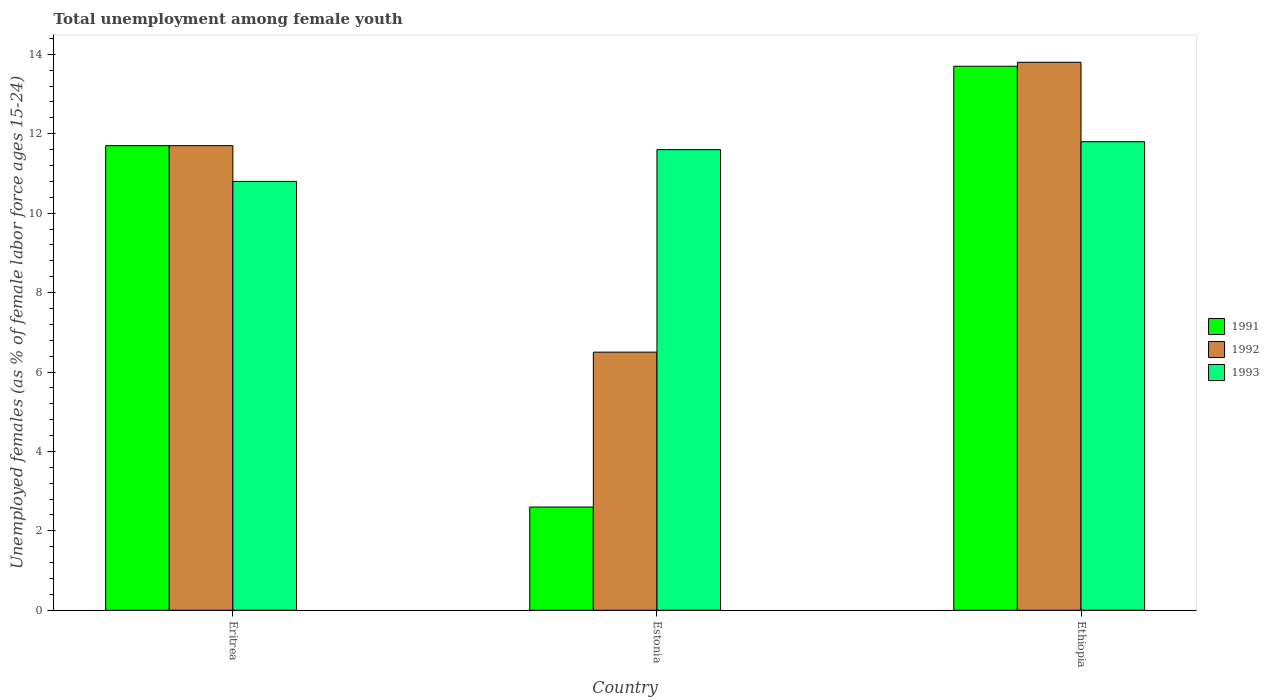Are the number of bars per tick equal to the number of legend labels?
Your response must be concise. Yes. How many bars are there on the 3rd tick from the left?
Keep it short and to the point. 3. What is the label of the 1st group of bars from the left?
Your answer should be very brief. Eritrea. What is the percentage of unemployed females in in 1993 in Ethiopia?
Offer a terse response. 11.8. Across all countries, what is the maximum percentage of unemployed females in in 1991?
Your answer should be very brief. 13.7. In which country was the percentage of unemployed females in in 1991 maximum?
Provide a succinct answer. Ethiopia. In which country was the percentage of unemployed females in in 1993 minimum?
Offer a very short reply. Eritrea. What is the total percentage of unemployed females in in 1991 in the graph?
Offer a very short reply. 28. What is the difference between the percentage of unemployed females in in 1992 in Eritrea and that in Ethiopia?
Offer a terse response. -2.1. What is the difference between the percentage of unemployed females in in 1992 in Ethiopia and the percentage of unemployed females in in 1991 in Estonia?
Ensure brevity in your answer.  11.2. What is the average percentage of unemployed females in in 1993 per country?
Your response must be concise. 11.4. What is the difference between the percentage of unemployed females in of/in 1993 and percentage of unemployed females in of/in 1991 in Eritrea?
Keep it short and to the point. -0.9. What is the ratio of the percentage of unemployed females in in 1993 in Estonia to that in Ethiopia?
Your answer should be compact. 0.98. Is the difference between the percentage of unemployed females in in 1993 in Estonia and Ethiopia greater than the difference between the percentage of unemployed females in in 1991 in Estonia and Ethiopia?
Provide a succinct answer. Yes. What is the difference between the highest and the second highest percentage of unemployed females in in 1991?
Keep it short and to the point. -9.1. What is the difference between the highest and the lowest percentage of unemployed females in in 1991?
Ensure brevity in your answer.  11.1. In how many countries, is the percentage of unemployed females in in 1993 greater than the average percentage of unemployed females in in 1993 taken over all countries?
Offer a very short reply. 2. What does the 3rd bar from the left in Ethiopia represents?
Provide a short and direct response. 1993. How many bars are there?
Provide a succinct answer. 9. Does the graph contain any zero values?
Ensure brevity in your answer.  No. Does the graph contain grids?
Ensure brevity in your answer.  No. Where does the legend appear in the graph?
Keep it short and to the point. Center right. How many legend labels are there?
Keep it short and to the point. 3. What is the title of the graph?
Keep it short and to the point. Total unemployment among female youth. Does "1994" appear as one of the legend labels in the graph?
Your answer should be very brief. No. What is the label or title of the Y-axis?
Make the answer very short. Unemployed females (as % of female labor force ages 15-24). What is the Unemployed females (as % of female labor force ages 15-24) of 1991 in Eritrea?
Provide a short and direct response. 11.7. What is the Unemployed females (as % of female labor force ages 15-24) of 1992 in Eritrea?
Give a very brief answer. 11.7. What is the Unemployed females (as % of female labor force ages 15-24) of 1993 in Eritrea?
Give a very brief answer. 10.8. What is the Unemployed females (as % of female labor force ages 15-24) of 1991 in Estonia?
Ensure brevity in your answer.  2.6. What is the Unemployed females (as % of female labor force ages 15-24) in 1993 in Estonia?
Keep it short and to the point. 11.6. What is the Unemployed females (as % of female labor force ages 15-24) in 1991 in Ethiopia?
Offer a very short reply. 13.7. What is the Unemployed females (as % of female labor force ages 15-24) in 1992 in Ethiopia?
Your response must be concise. 13.8. What is the Unemployed females (as % of female labor force ages 15-24) of 1993 in Ethiopia?
Your answer should be compact. 11.8. Across all countries, what is the maximum Unemployed females (as % of female labor force ages 15-24) of 1991?
Offer a very short reply. 13.7. Across all countries, what is the maximum Unemployed females (as % of female labor force ages 15-24) in 1992?
Provide a succinct answer. 13.8. Across all countries, what is the maximum Unemployed females (as % of female labor force ages 15-24) of 1993?
Keep it short and to the point. 11.8. Across all countries, what is the minimum Unemployed females (as % of female labor force ages 15-24) of 1991?
Provide a short and direct response. 2.6. Across all countries, what is the minimum Unemployed females (as % of female labor force ages 15-24) of 1992?
Ensure brevity in your answer.  6.5. Across all countries, what is the minimum Unemployed females (as % of female labor force ages 15-24) of 1993?
Provide a short and direct response. 10.8. What is the total Unemployed females (as % of female labor force ages 15-24) in 1991 in the graph?
Provide a succinct answer. 28. What is the total Unemployed females (as % of female labor force ages 15-24) of 1993 in the graph?
Provide a succinct answer. 34.2. What is the difference between the Unemployed females (as % of female labor force ages 15-24) of 1993 in Eritrea and that in Estonia?
Your response must be concise. -0.8. What is the difference between the Unemployed females (as % of female labor force ages 15-24) of 1991 in Eritrea and that in Ethiopia?
Offer a terse response. -2. What is the difference between the Unemployed females (as % of female labor force ages 15-24) in 1992 in Estonia and that in Ethiopia?
Provide a short and direct response. -7.3. What is the difference between the Unemployed females (as % of female labor force ages 15-24) in 1992 in Eritrea and the Unemployed females (as % of female labor force ages 15-24) in 1993 in Estonia?
Offer a terse response. 0.1. What is the difference between the Unemployed females (as % of female labor force ages 15-24) of 1991 in Eritrea and the Unemployed females (as % of female labor force ages 15-24) of 1993 in Ethiopia?
Your answer should be very brief. -0.1. What is the average Unemployed females (as % of female labor force ages 15-24) in 1991 per country?
Your response must be concise. 9.33. What is the average Unemployed females (as % of female labor force ages 15-24) in 1992 per country?
Provide a short and direct response. 10.67. What is the difference between the Unemployed females (as % of female labor force ages 15-24) in 1991 and Unemployed females (as % of female labor force ages 15-24) in 1993 in Eritrea?
Provide a short and direct response. 0.9. What is the difference between the Unemployed females (as % of female labor force ages 15-24) in 1992 and Unemployed females (as % of female labor force ages 15-24) in 1993 in Eritrea?
Offer a very short reply. 0.9. What is the difference between the Unemployed females (as % of female labor force ages 15-24) of 1991 and Unemployed females (as % of female labor force ages 15-24) of 1993 in Estonia?
Keep it short and to the point. -9. What is the difference between the Unemployed females (as % of female labor force ages 15-24) in 1991 and Unemployed females (as % of female labor force ages 15-24) in 1992 in Ethiopia?
Give a very brief answer. -0.1. What is the difference between the Unemployed females (as % of female labor force ages 15-24) of 1991 and Unemployed females (as % of female labor force ages 15-24) of 1993 in Ethiopia?
Offer a terse response. 1.9. What is the ratio of the Unemployed females (as % of female labor force ages 15-24) of 1991 in Eritrea to that in Estonia?
Your answer should be very brief. 4.5. What is the ratio of the Unemployed females (as % of female labor force ages 15-24) of 1992 in Eritrea to that in Estonia?
Your answer should be compact. 1.8. What is the ratio of the Unemployed females (as % of female labor force ages 15-24) in 1991 in Eritrea to that in Ethiopia?
Your answer should be very brief. 0.85. What is the ratio of the Unemployed females (as % of female labor force ages 15-24) in 1992 in Eritrea to that in Ethiopia?
Keep it short and to the point. 0.85. What is the ratio of the Unemployed females (as % of female labor force ages 15-24) of 1993 in Eritrea to that in Ethiopia?
Offer a terse response. 0.92. What is the ratio of the Unemployed females (as % of female labor force ages 15-24) in 1991 in Estonia to that in Ethiopia?
Make the answer very short. 0.19. What is the ratio of the Unemployed females (as % of female labor force ages 15-24) of 1992 in Estonia to that in Ethiopia?
Your response must be concise. 0.47. What is the ratio of the Unemployed females (as % of female labor force ages 15-24) in 1993 in Estonia to that in Ethiopia?
Make the answer very short. 0.98. What is the difference between the highest and the second highest Unemployed females (as % of female labor force ages 15-24) in 1992?
Offer a terse response. 2.1. What is the difference between the highest and the lowest Unemployed females (as % of female labor force ages 15-24) of 1991?
Your response must be concise. 11.1. What is the difference between the highest and the lowest Unemployed females (as % of female labor force ages 15-24) of 1992?
Provide a short and direct response. 7.3. 